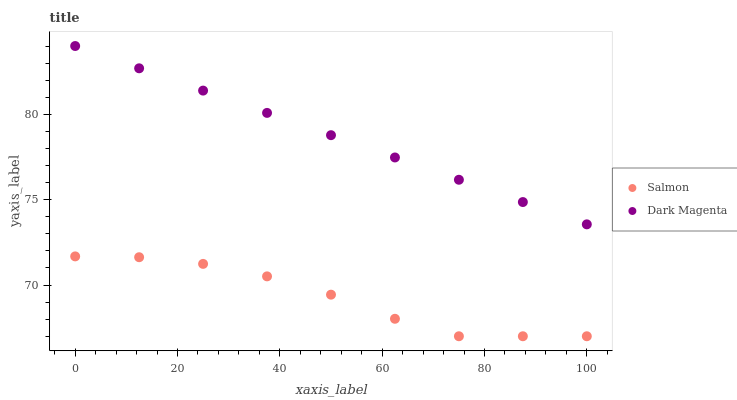Does Salmon have the minimum area under the curve?
Answer yes or no. Yes. Does Dark Magenta have the maximum area under the curve?
Answer yes or no. Yes. Does Dark Magenta have the minimum area under the curve?
Answer yes or no. No. Is Dark Magenta the smoothest?
Answer yes or no. Yes. Is Salmon the roughest?
Answer yes or no. Yes. Is Dark Magenta the roughest?
Answer yes or no. No. Does Salmon have the lowest value?
Answer yes or no. Yes. Does Dark Magenta have the lowest value?
Answer yes or no. No. Does Dark Magenta have the highest value?
Answer yes or no. Yes. Is Salmon less than Dark Magenta?
Answer yes or no. Yes. Is Dark Magenta greater than Salmon?
Answer yes or no. Yes. Does Salmon intersect Dark Magenta?
Answer yes or no. No. 